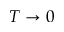<formula> <loc_0><loc_0><loc_500><loc_500>T \rightarrow 0</formula> 